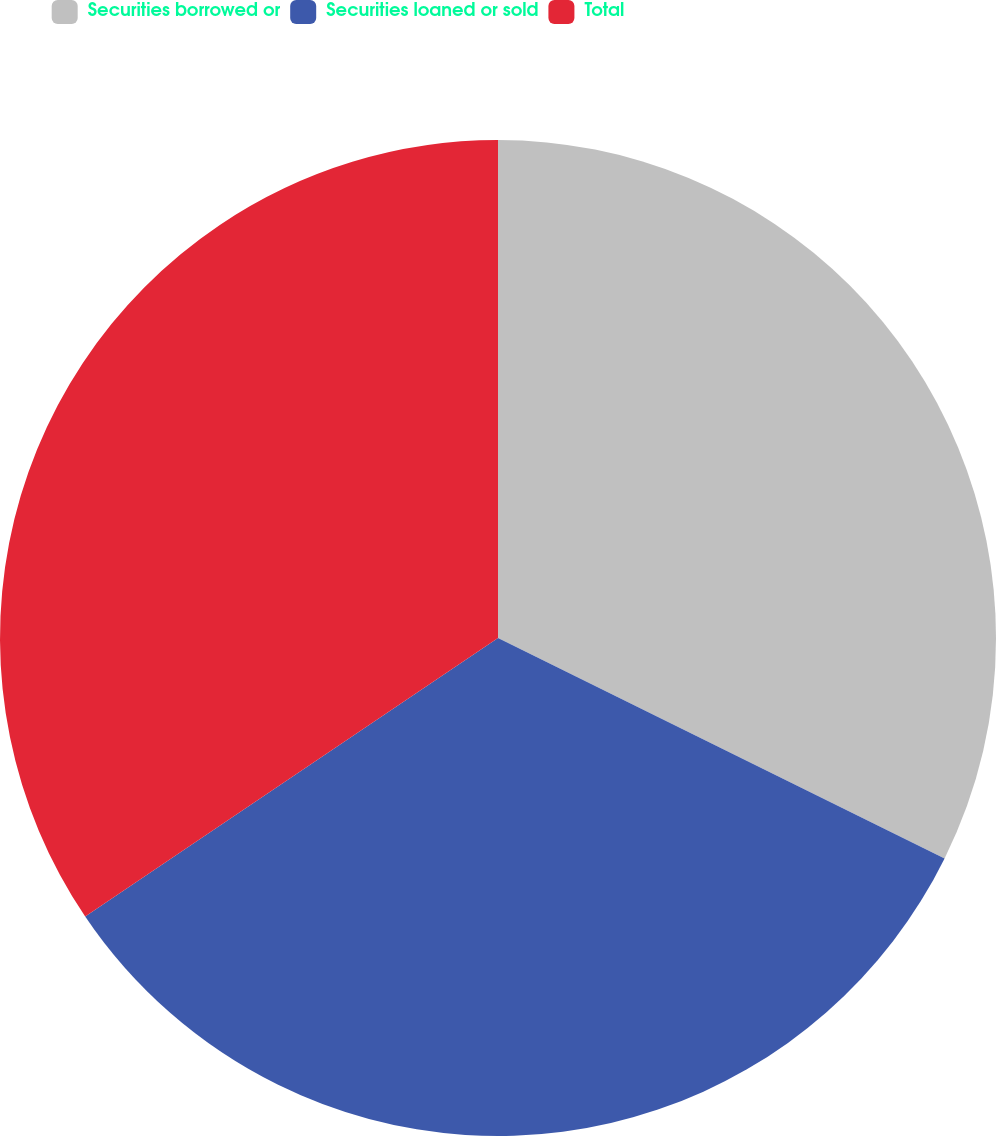Convert chart to OTSL. <chart><loc_0><loc_0><loc_500><loc_500><pie_chart><fcel>Securities borrowed or<fcel>Securities loaned or sold<fcel>Total<nl><fcel>32.3%<fcel>33.26%<fcel>34.45%<nl></chart> 